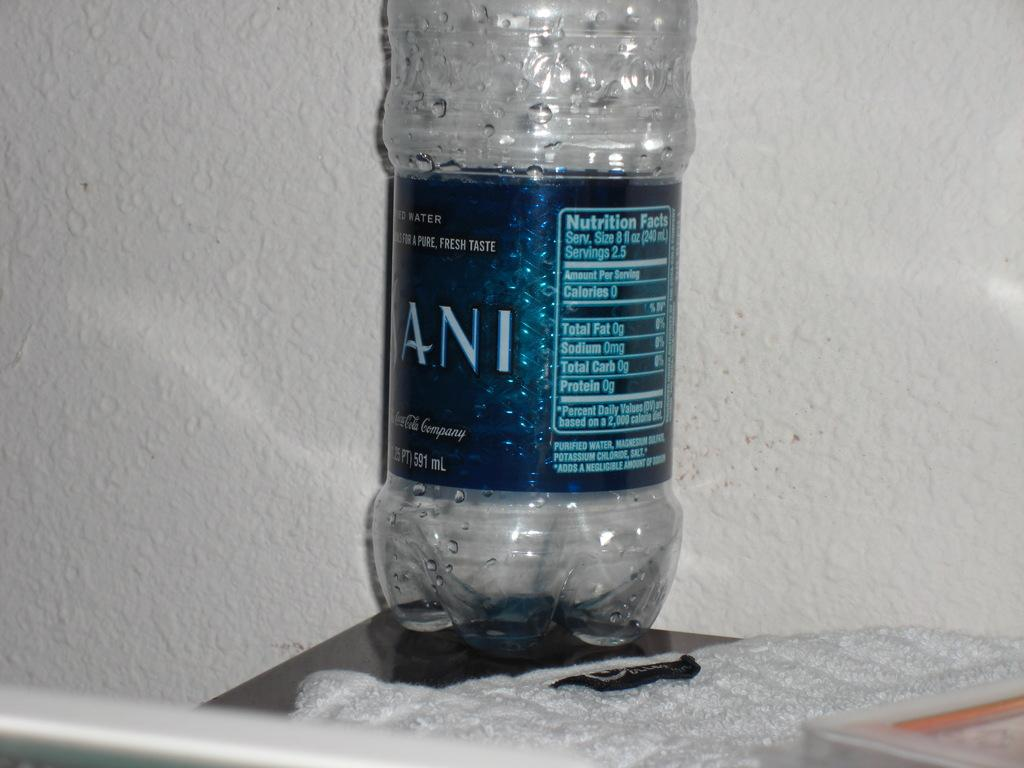<image>
Provide a brief description of the given image. an empty Dansani water bottle with a "pure, fresh taste" on a desk 